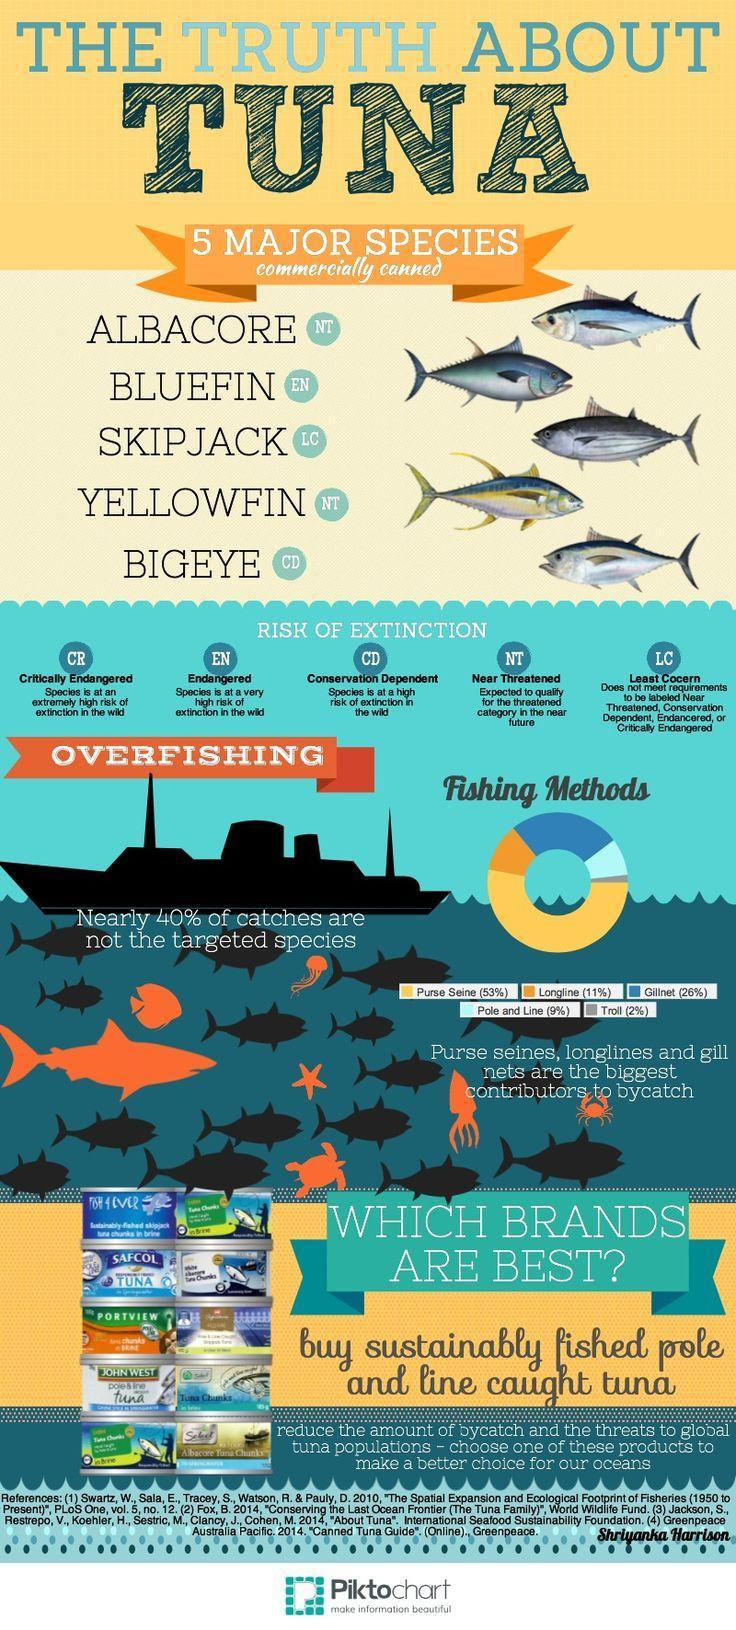How many brands of tuna are shown here?
Answer the question with a short phrase. 10 What does CR stand for? Critically endangered Which is the most commonly used method of fishing? Purse seine How many methods of fishing are mentioned here? 5 Which tuna species is "conservation dependent"? Bigeye Which fishing method is less popular -  long line, pole and line or Gillnet? Pole and line Depending on the risk of extinction, into how many categories/groups can the species be divided? 5 Which is the least used method of fishing? Troll What percent of the catches are the targeted species? 60% Which risk group has a higher risk of extinction - LC, CD or CR? CR Which tuna species is endangered? Bluefin Which is the second most commonly used method of fishing? Gillnet What does EN stand for? Endangered What percentage of the catch is by "longline"  method? 11% To which risk of extinction does the species Skip jack belong - EN, LC, CR or CD? LC Which of the the tuna species are "near threatened" ? Yellowfin, Albacore 